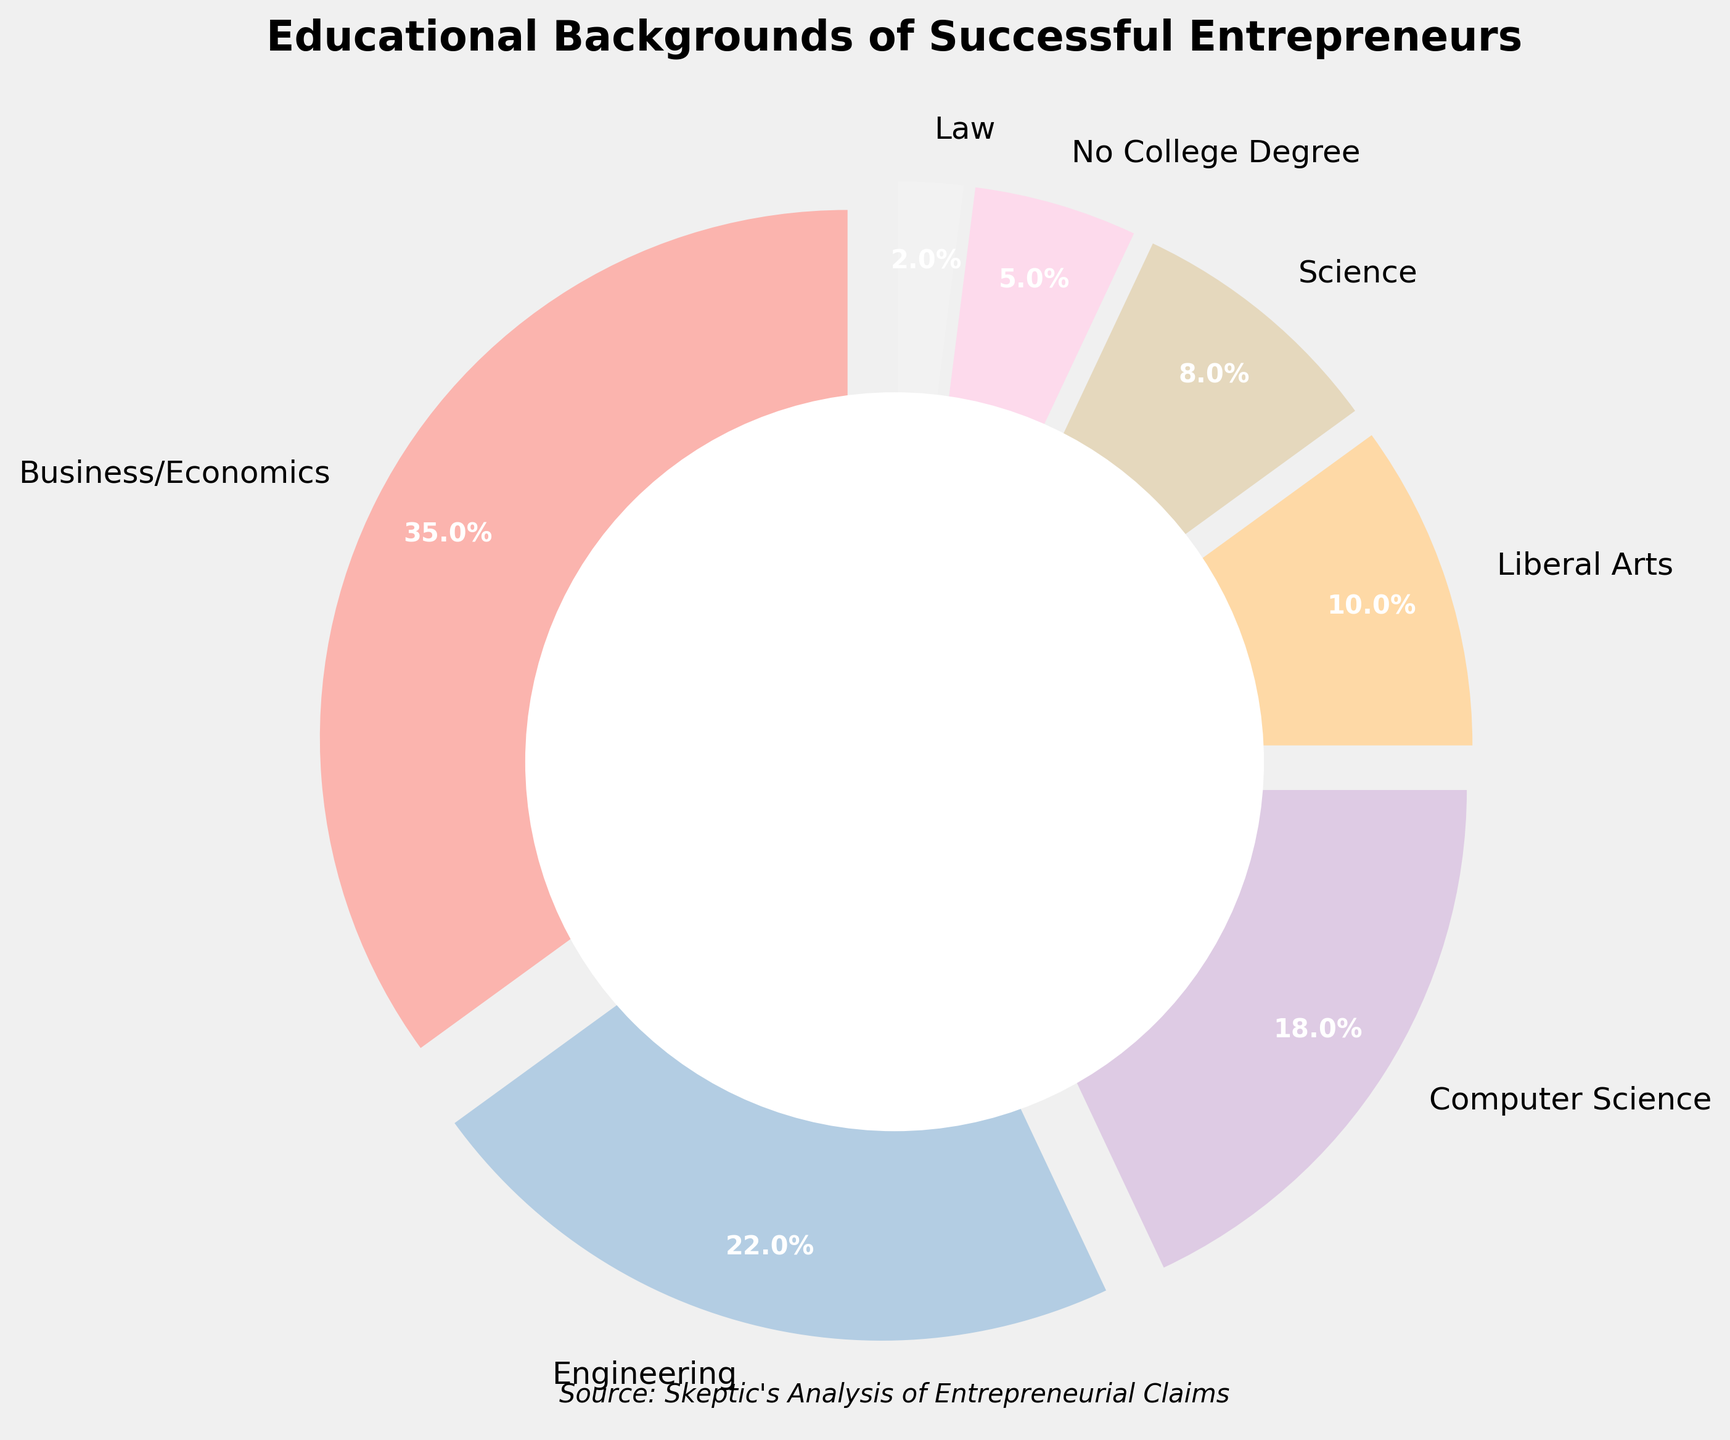What educational background has the highest percentage among successful entrepreneurs? By visually inspecting the pie chart, the segment labeled "Business/Economics" is the largest portion, which indicates it has the highest percentage.
Answer: Business/Economics Which educational backgrounds have percentages less than 10%? By examining the figure, the segments labeled "Liberal Arts", "Science", "No College Degree", and "Law" represent the portions less than 10%.
Answer: Liberal Arts, Science, No College Degree, Law What is the sum of the percentages for Computer Science, Engineering, and Science backgrounds? To find the sum, locate each of the corresponding segments: "Computer Science" is 18%, "Engineering" is 22%, and "Science" is 8%. Sum these values: 18 + 22 + 8.
Answer: 48% How does the percentage of Business/Economics compare to the sum of Liberal Arts and No College Degree? The Business/Economics segment is 35%. Liberal Arts is 10% and No College Degree is 5%. Sum the latter values: 10 + 5 = 15. Compare 35 to 15.
Answer: Business/Economics has a higher percentage What is the difference in percentage between Engineering and Science backgrounds? Identify the segments: Engineering is 22% and Science is 8%. Subtract the smaller value from the larger one: 22 - 8.
Answer: 14% Which segment is the smallest, and what color represents it? The "Law" segment is the smallest portion at 2%. Its corresponding color can be identified visually from the pie chart.
Answer: Law, depends on the pie chart's rendered colors (likely a soft pastel shade) What portion of the pie chart is taken by backgrounds in STEM fields (Science, Technology, Engineering, Math)? Locate the segments for Science (8%), Computer Science (18%), and Engineering (22%). Sum these values: 8 + 18 + 22.
Answer: 48% If one wanted to eliminate one background to create an even number of categories, which one should be removed to minimally affect the pie chart distribution? From the given percentages, removing "Law" (2%) would have the least impact since it has the smallest percentage.
Answer: Law Is there any category that makes up exactly or close to one-third of the pie chart? One-third of the pie chart is approximately 33.33%. The "Business/Economics" segment is 35%, which is close to 33.33%.
Answer: Business/Economics What is the combined percentage of non-STEM educational backgrounds? Non-STEM includes Business/Economics (35%), Liberal Arts (10%), No College Degree (5%), Law (2%). Sum these values: 35 + 10 + 5 + 2.
Answer: 52% 